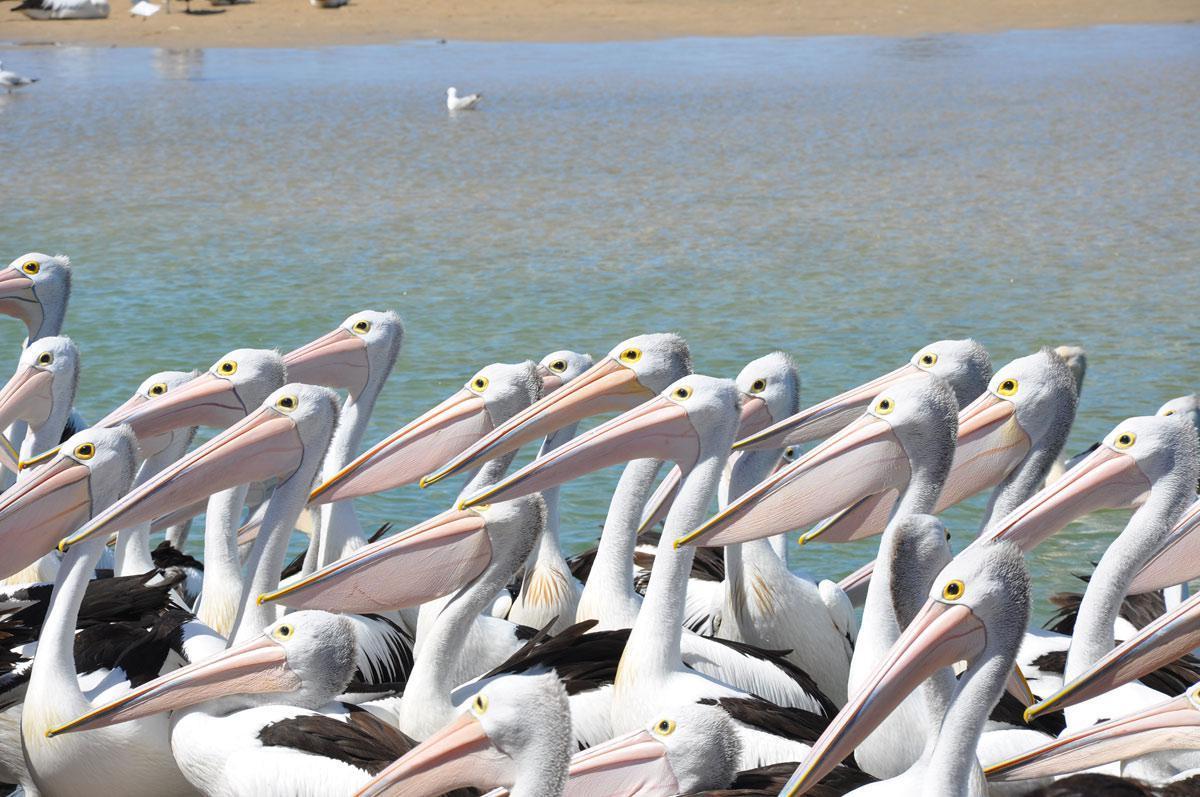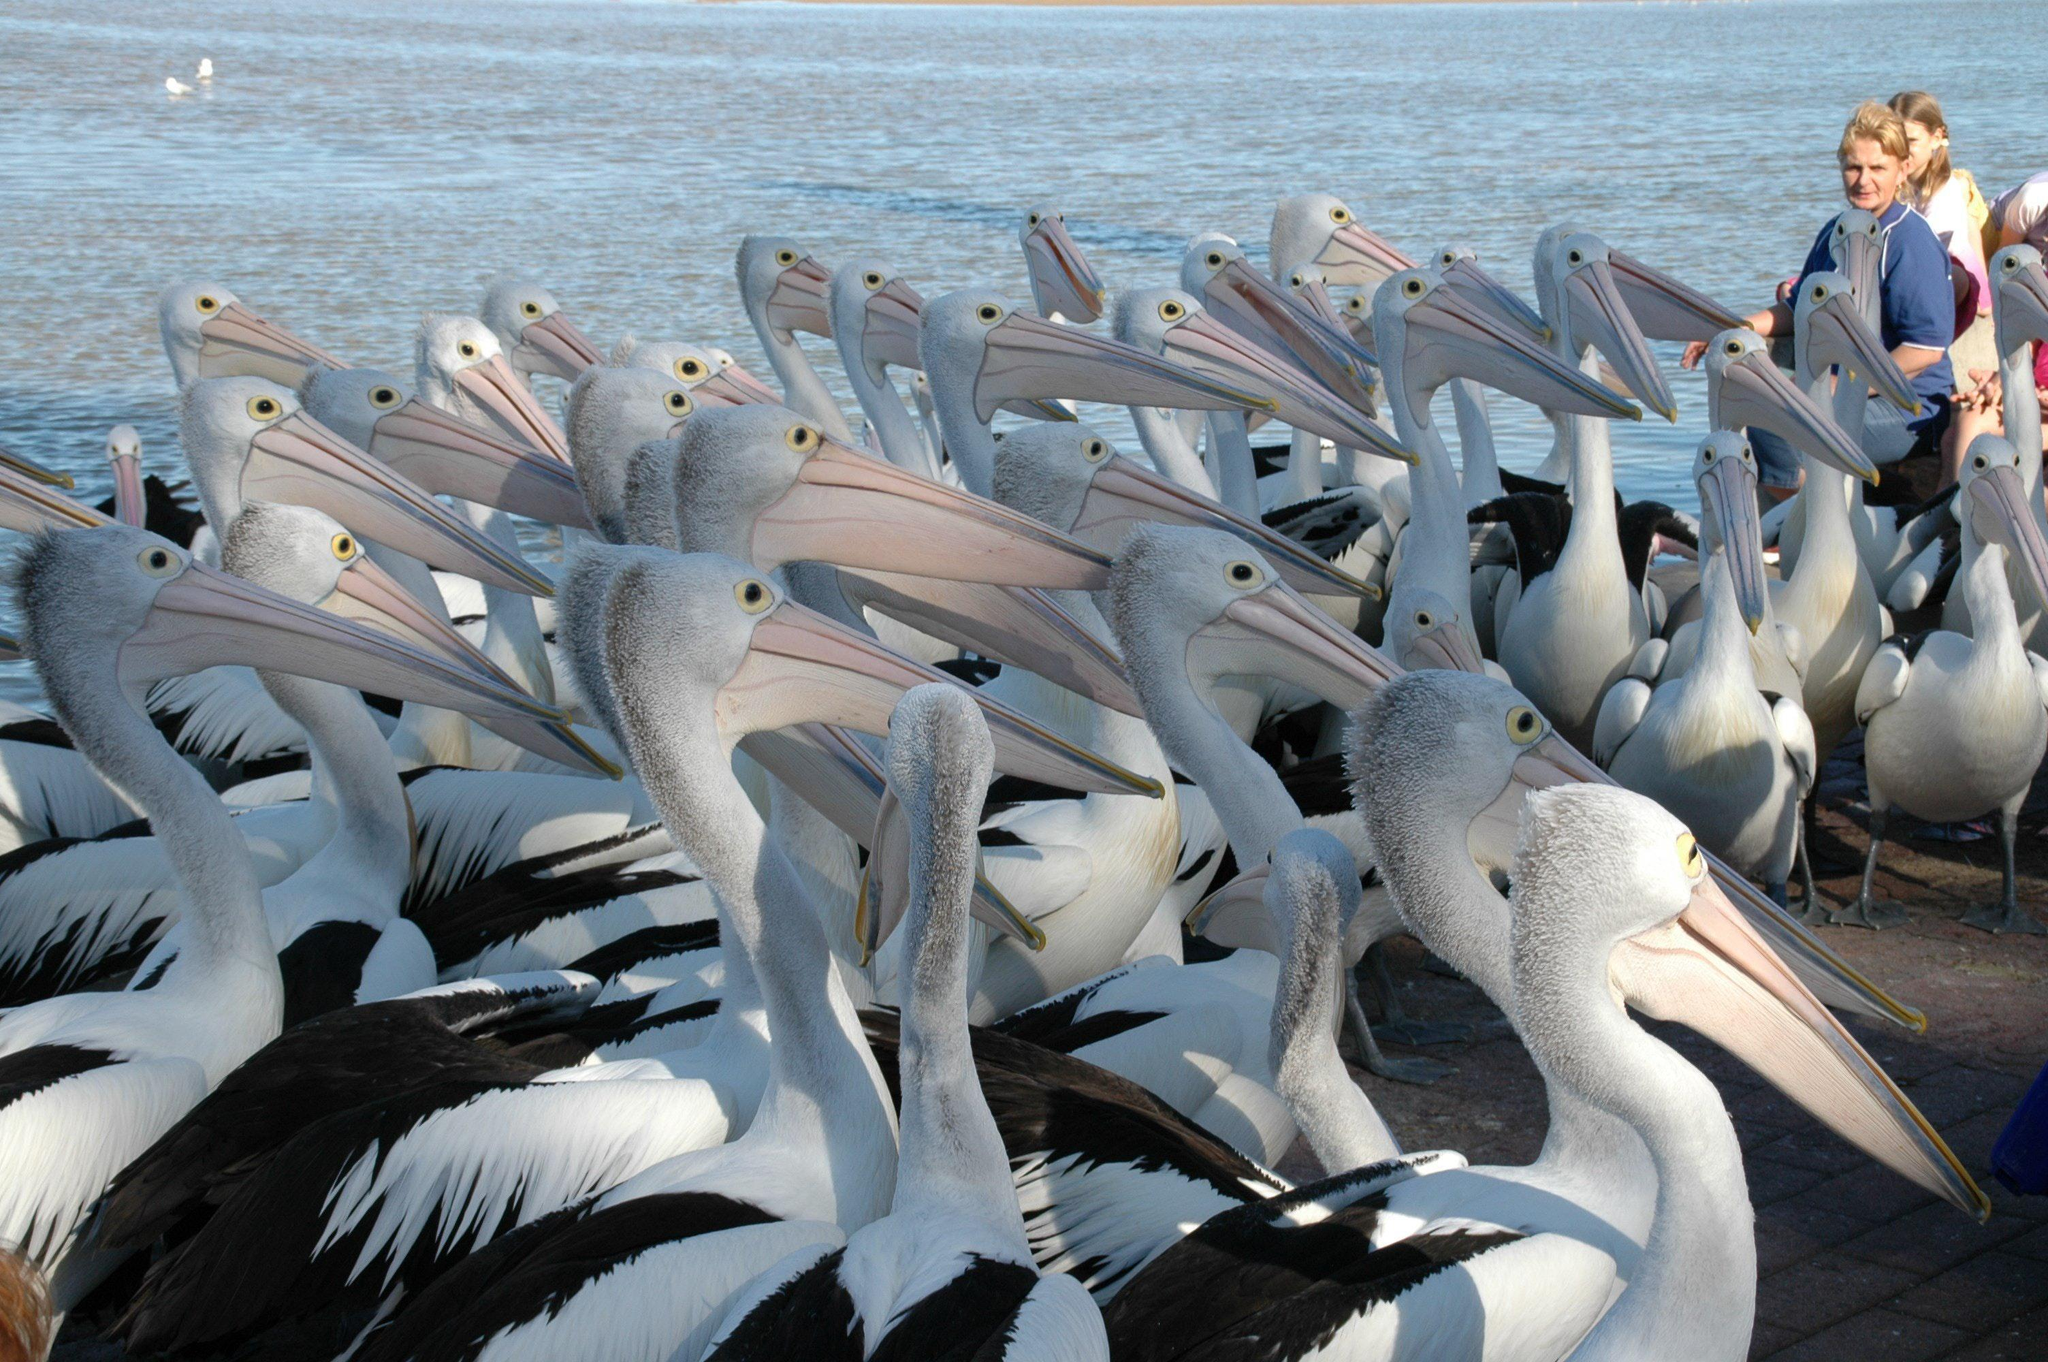The first image is the image on the left, the second image is the image on the right. Examine the images to the left and right. Is the description "There are at least eight pelicans facing left with no more than four people visible in the right side of the photo." accurate? Answer yes or no. Yes. The first image is the image on the left, the second image is the image on the right. Considering the images on both sides, is "In at least one of the images, every single bird is facing to the left." valid? Answer yes or no. Yes. 